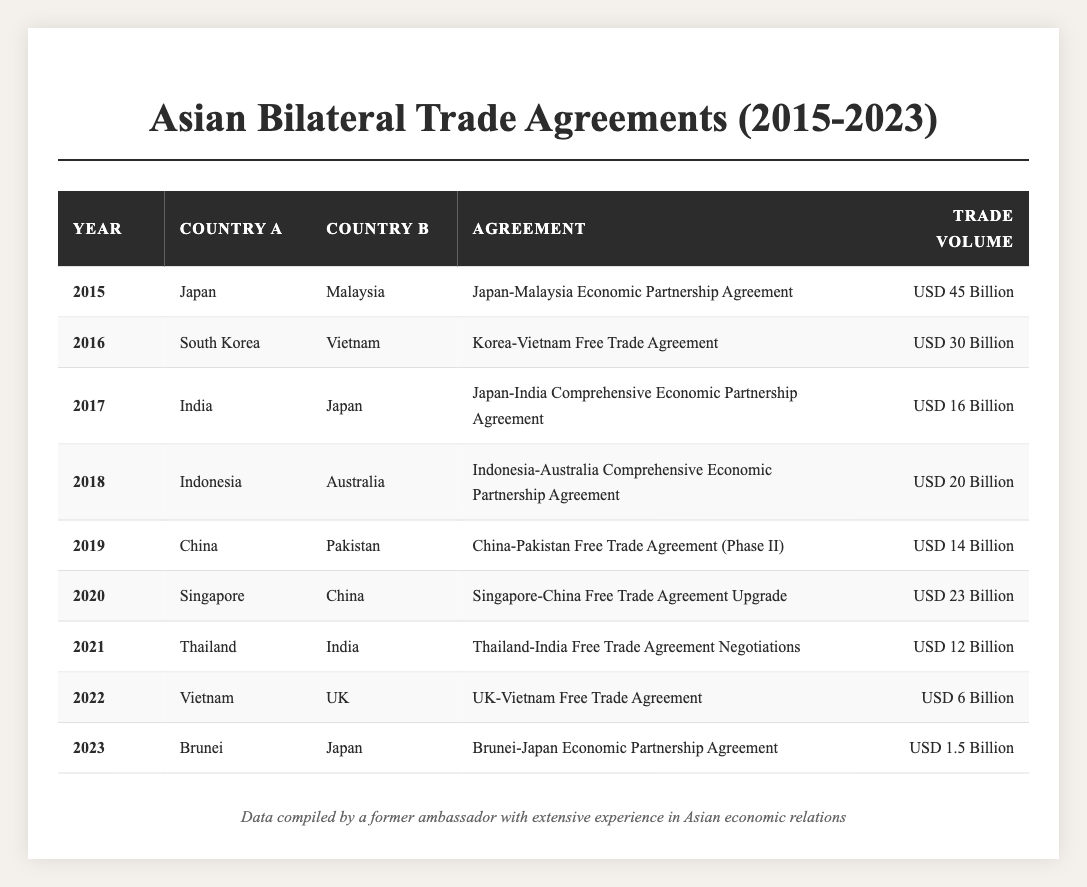What is the trade volume of the Japan-Malaysia Economic Partnership Agreement? The trade volume can be found in the row for the year 2015, which states 'USD 45 Billion' for the Japan-Malaysia Economic Partnership Agreement.
Answer: USD 45 Billion Which two countries signed an agreement in 2016? In 2016, South Korea and Vietnam signed the Korea-Vietnam Free Trade Agreement.
Answer: South Korea and Vietnam What was the total trade volume of agreements signed from 2015 to 2018? Adding the trade volumes from 2015 (45), 2016 (30), 2017 (16), and 2018 (20) gives a total of 111 Billion: 45 + 30 + 16 + 20 = 111.
Answer: USD 111 Billion Is the trade volume of the Brunei-Japan Economic Partnership Agreement greater than USD 2 Billion? The trade volume for the Brunei-Japan Economic Partnership Agreement in 2023 is USD 1.5 Billion, which is less than USD 2 Billion.
Answer: No What are the years in which India was involved in a bilateral trade agreement? India was involved in agreements in 2017 and 2021 as seen for the Japan-India CEPA and Thailand-India FTA.
Answer: 2017 and 2021 What is the average trade volume of the agreements listed from 2015 to 2023? The sum of trade volumes is 45 + 30 + 16 + 20 + 14 + 23 + 12 + 6 + 1.5 = 167.5 Billion, and there are 9 agreements, thus averaging is 167.5/9 = 18.67.
Answer: USD 18.67 Billion Which agreement has the lowest trade volume? The Brunei-Japan Economic Partnership Agreement has the lowest trade volume of USD 1.5 Billion, as shown in the 2023 data.
Answer: USD 1.5 Billion How many agreements were signed in 2020 and 2021 combined? In 2020, there was 1 agreement (Singapore-China), and in 2021, there was 1 agreement (Thailand-India), making a total of 2 agreements signed in those years.
Answer: 2 agreements Did Vietnam sign any agreements with countries outside Asia during this period? Vietnam signed the UK-Vietnam Free Trade Agreement in 2022 with the UK, which is not an Asian country.
Answer: Yes What is the trade volume difference between the agreements signed in 2016 and 2022? The trade volume in 2016 was USD 30 Billion (Korea-Vietnam), and in 2022 it was USD 6 Billion (UK-Vietnam), so the difference is 30 - 6 = 24 Billion.
Answer: USD 24 Billion 